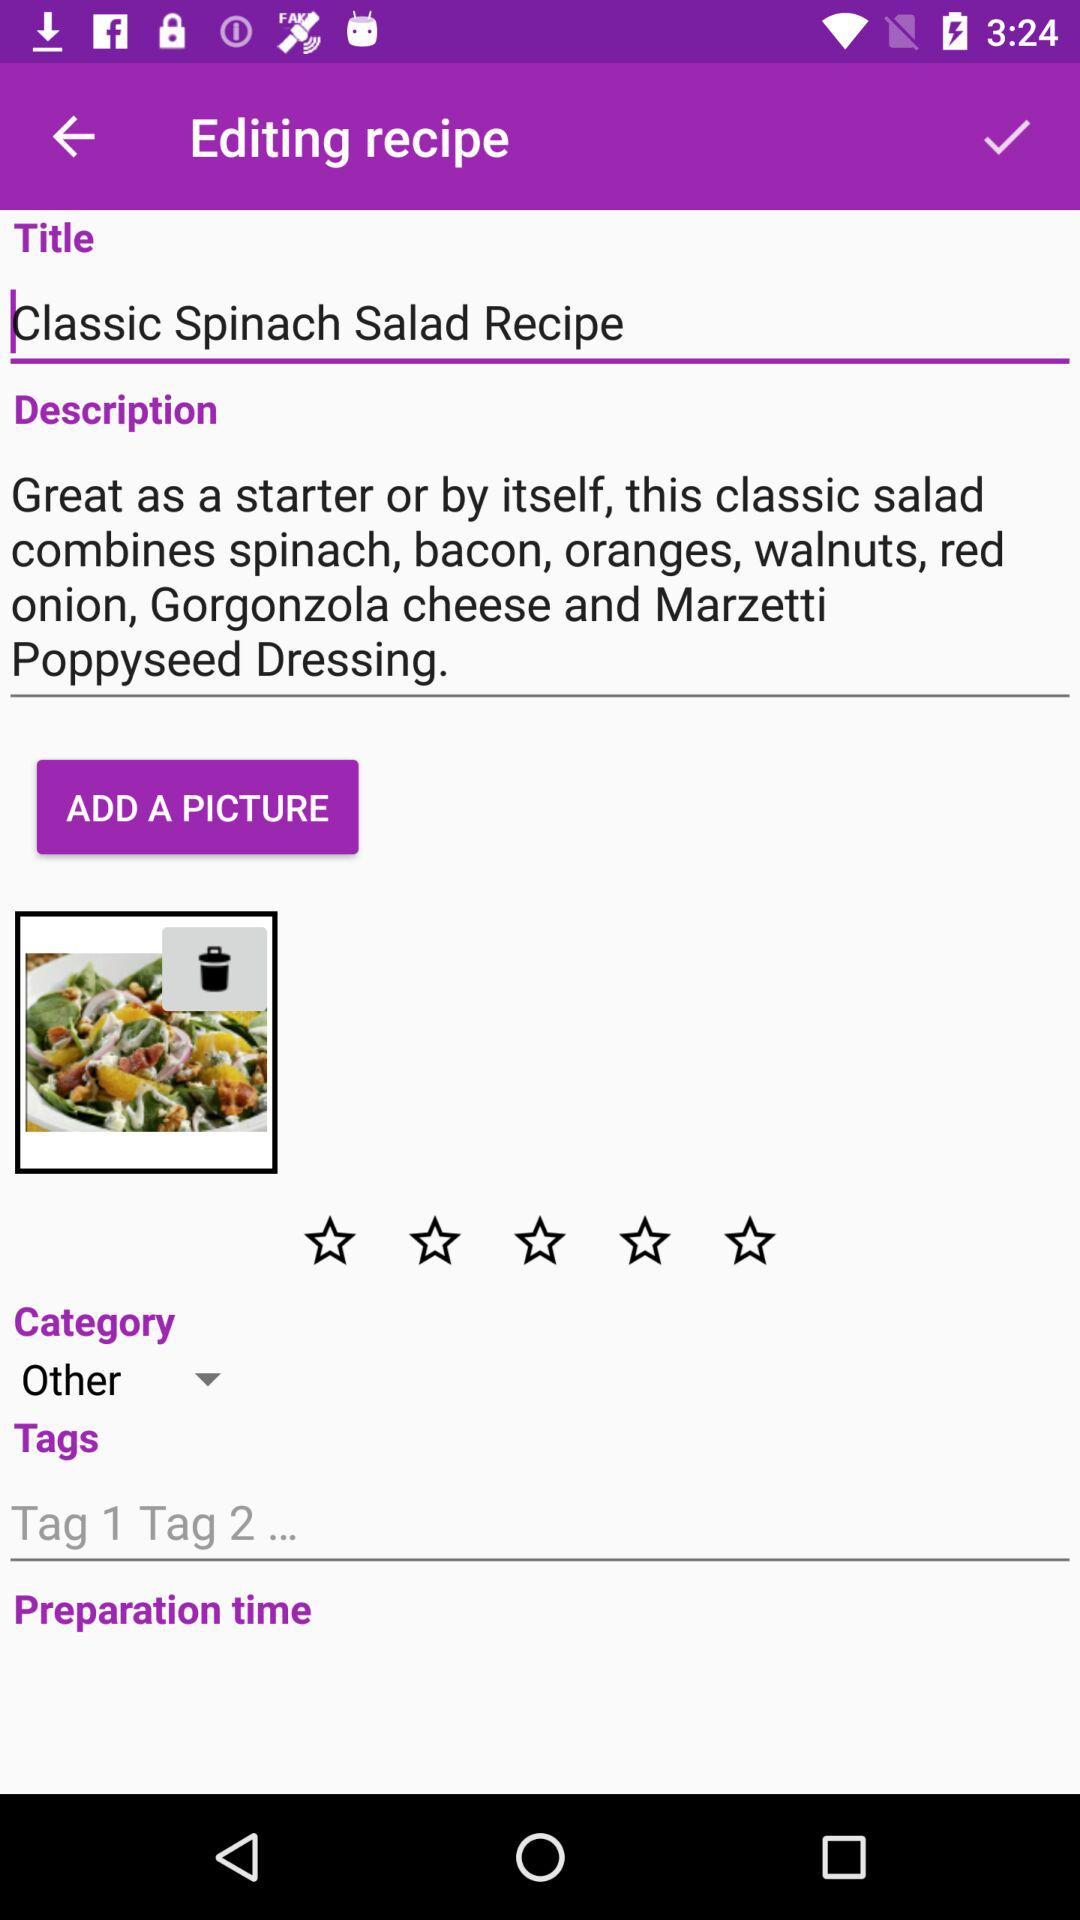Which category is selected? The selected category is "Other". 